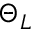<formula> <loc_0><loc_0><loc_500><loc_500>\Theta _ { L }</formula> 